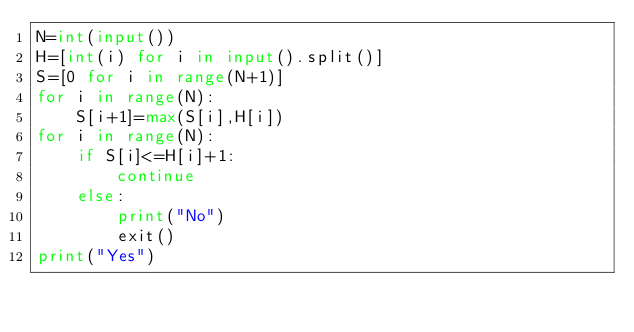<code> <loc_0><loc_0><loc_500><loc_500><_Python_>N=int(input())
H=[int(i) for i in input().split()]
S=[0 for i in range(N+1)]
for i in range(N):
    S[i+1]=max(S[i],H[i])
for i in range(N):
    if S[i]<=H[i]+1:
        continue
    else:
        print("No")
        exit()
print("Yes")</code> 